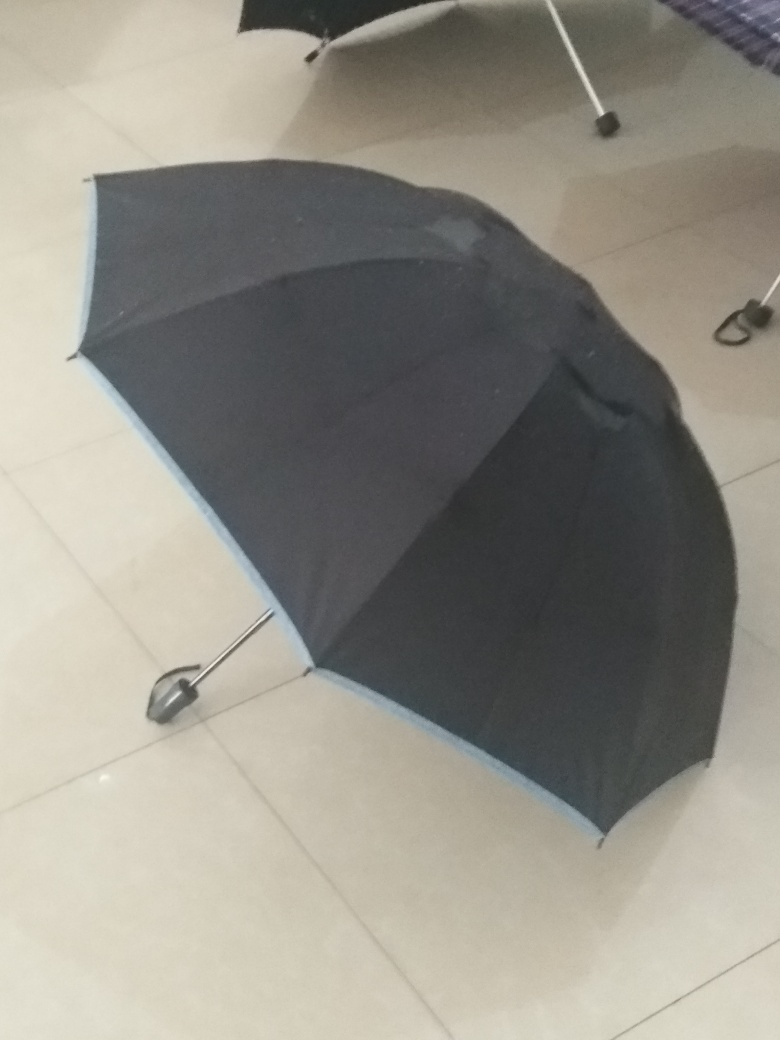What can you tell me about the item in the image? The item in the image is a black and blue umbrella with an elongated handle. It's placed on a flat, light-colored tiled floor. The umbrella is partially open, suggesting it was either left to dry or was abandoned in a hurry. 